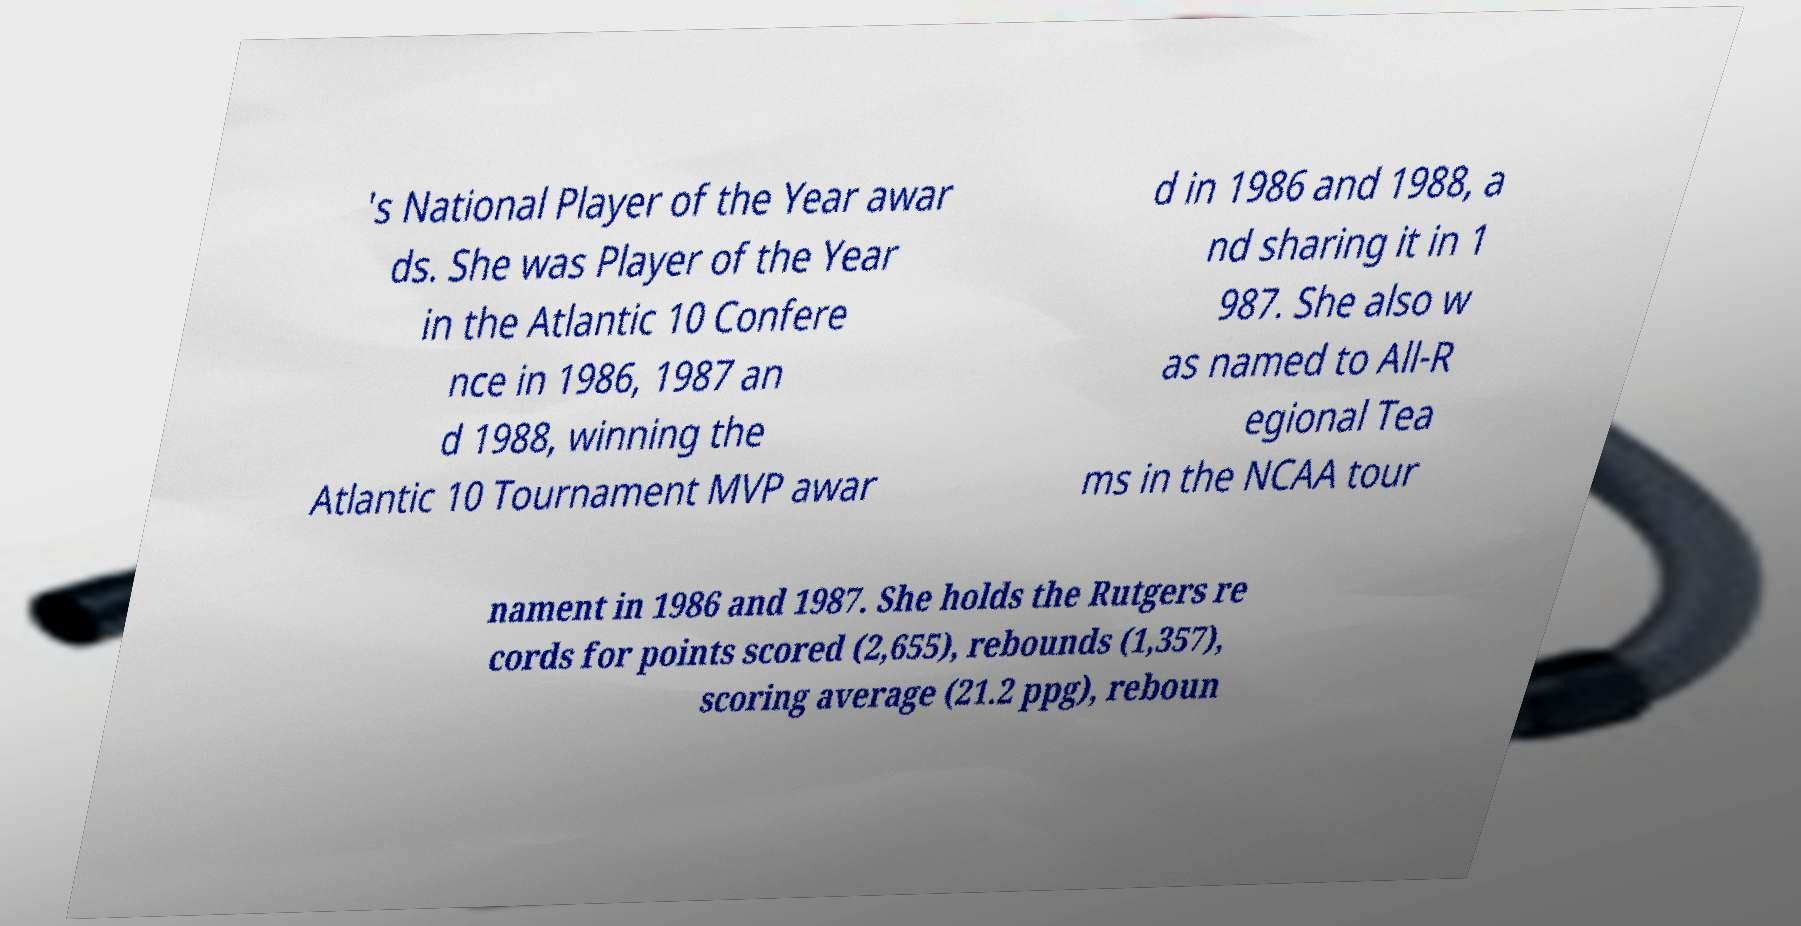Could you assist in decoding the text presented in this image and type it out clearly? 's National Player of the Year awar ds. She was Player of the Year in the Atlantic 10 Confere nce in 1986, 1987 an d 1988, winning the Atlantic 10 Tournament MVP awar d in 1986 and 1988, a nd sharing it in 1 987. She also w as named to All-R egional Tea ms in the NCAA tour nament in 1986 and 1987. She holds the Rutgers re cords for points scored (2,655), rebounds (1,357), scoring average (21.2 ppg), reboun 